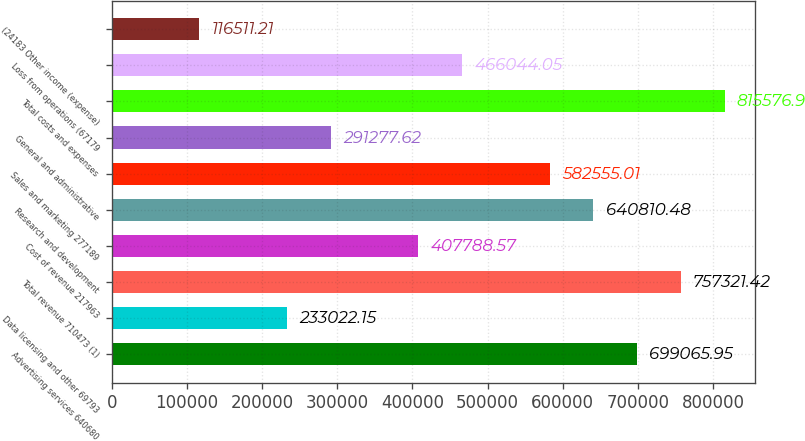Convert chart to OTSL. <chart><loc_0><loc_0><loc_500><loc_500><bar_chart><fcel>Advertising services 640680<fcel>Data licensing and other 69793<fcel>Total revenue 710473 (1)<fcel>Cost of revenue 217963<fcel>Research and development<fcel>Sales and marketing 277189<fcel>General and administrative<fcel>Total costs and expenses<fcel>Loss from operations (67179<fcel>(24183 Other income (expense)<nl><fcel>699066<fcel>233022<fcel>757321<fcel>407789<fcel>640810<fcel>582555<fcel>291278<fcel>815577<fcel>466044<fcel>116511<nl></chart> 